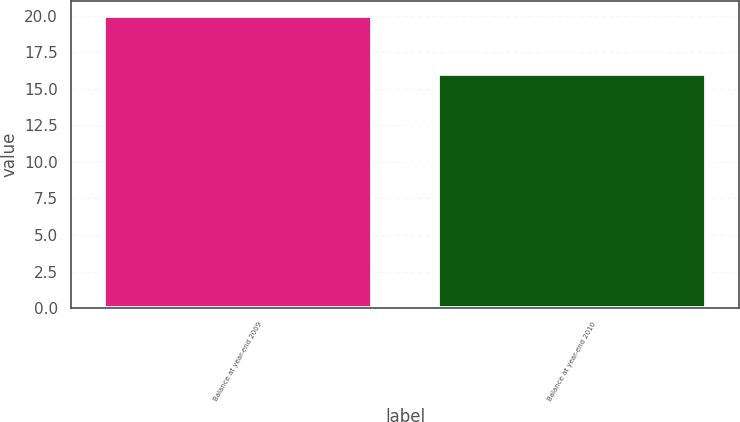<chart> <loc_0><loc_0><loc_500><loc_500><bar_chart><fcel>Balance at year-end 2009<fcel>Balance at year-end 2010<nl><fcel>20<fcel>16<nl></chart> 